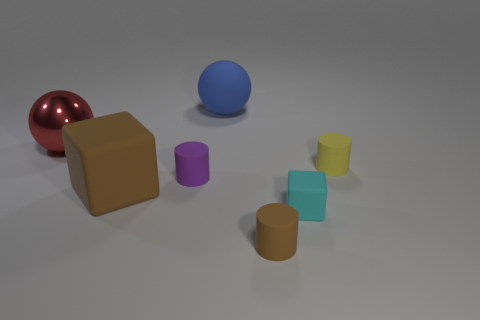Add 1 rubber cylinders. How many objects exist? 8 Subtract all cubes. How many objects are left? 5 Add 1 big blue matte objects. How many big blue matte objects exist? 2 Subtract 1 brown cylinders. How many objects are left? 6 Subtract all large brown matte cylinders. Subtract all brown cylinders. How many objects are left? 6 Add 1 tiny brown objects. How many tiny brown objects are left? 2 